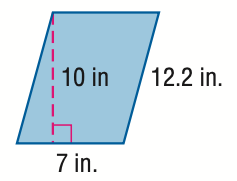Question: Find the area of the parallelogram. Round to the nearest tenth if necessary.
Choices:
A. 35
B. 38.4
C. 70
D. 140
Answer with the letter. Answer: C Question: Find the perimeter of the parallelogram. Round to the nearest tenth if necessary.
Choices:
A. 19.2
B. 38.4
C. 70.0
D. 76.8
Answer with the letter. Answer: B 